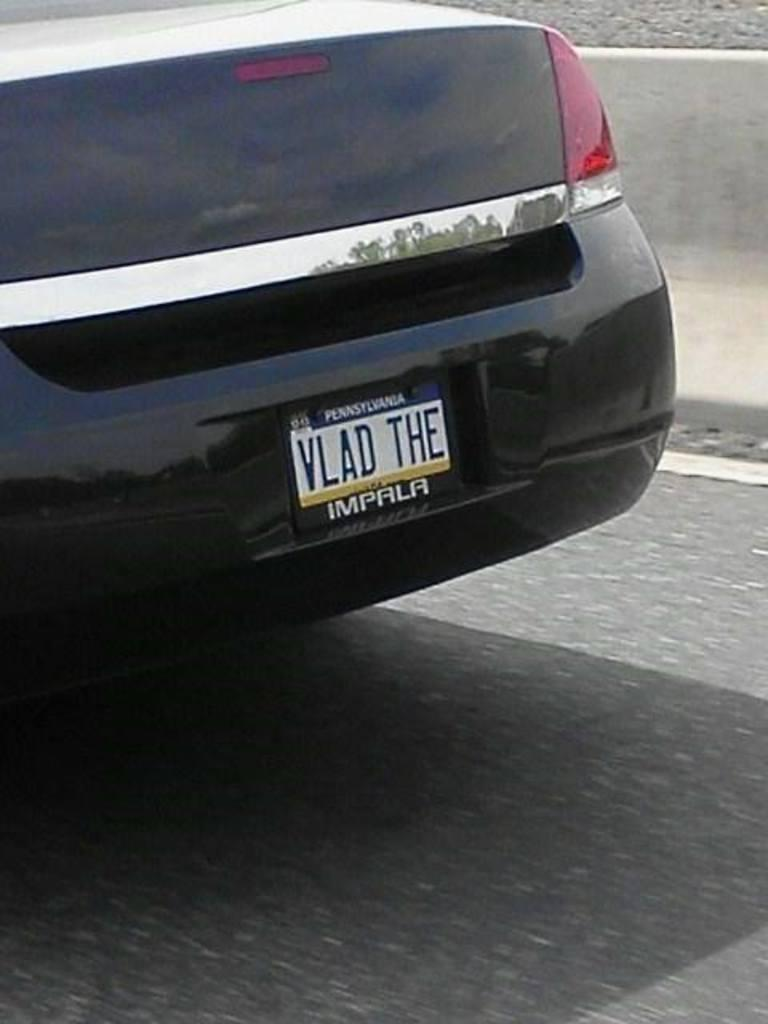What is the color of the vehicle on the road in the image? The vehicle on the road is black. What can be seen in the background of the image? There is a divider in the background. Are there any other roads visible in the image? Yes, there is another road near the divider. Where is the cobweb located in the image? There is no cobweb present in the image. 